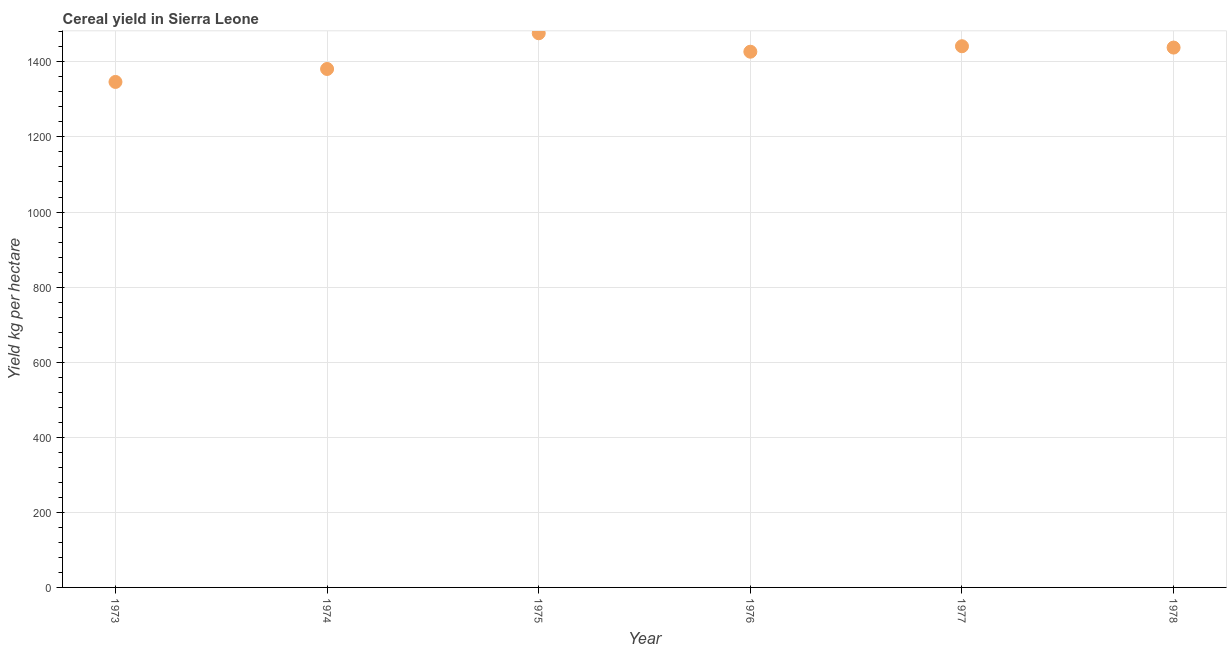What is the cereal yield in 1977?
Your answer should be very brief. 1441.64. Across all years, what is the maximum cereal yield?
Your answer should be very brief. 1476.21. Across all years, what is the minimum cereal yield?
Provide a short and direct response. 1346.54. In which year was the cereal yield maximum?
Your answer should be compact. 1975. What is the sum of the cereal yield?
Offer a terse response. 8510.59. What is the difference between the cereal yield in 1975 and 1976?
Ensure brevity in your answer.  49.15. What is the average cereal yield per year?
Give a very brief answer. 1418.43. What is the median cereal yield?
Give a very brief answer. 1432.57. In how many years, is the cereal yield greater than 80 kg per hectare?
Your answer should be very brief. 6. What is the ratio of the cereal yield in 1973 to that in 1976?
Your answer should be very brief. 0.94. Is the cereal yield in 1975 less than that in 1976?
Provide a succinct answer. No. What is the difference between the highest and the second highest cereal yield?
Provide a succinct answer. 34.56. What is the difference between the highest and the lowest cereal yield?
Give a very brief answer. 129.67. How many dotlines are there?
Give a very brief answer. 1. What is the difference between two consecutive major ticks on the Y-axis?
Make the answer very short. 200. Are the values on the major ticks of Y-axis written in scientific E-notation?
Your response must be concise. No. Does the graph contain grids?
Keep it short and to the point. Yes. What is the title of the graph?
Provide a short and direct response. Cereal yield in Sierra Leone. What is the label or title of the Y-axis?
Your answer should be very brief. Yield kg per hectare. What is the Yield kg per hectare in 1973?
Provide a succinct answer. 1346.54. What is the Yield kg per hectare in 1974?
Keep it short and to the point. 1381.07. What is the Yield kg per hectare in 1975?
Provide a succinct answer. 1476.21. What is the Yield kg per hectare in 1976?
Offer a very short reply. 1427.06. What is the Yield kg per hectare in 1977?
Your response must be concise. 1441.64. What is the Yield kg per hectare in 1978?
Keep it short and to the point. 1438.08. What is the difference between the Yield kg per hectare in 1973 and 1974?
Keep it short and to the point. -34.53. What is the difference between the Yield kg per hectare in 1973 and 1975?
Offer a very short reply. -129.67. What is the difference between the Yield kg per hectare in 1973 and 1976?
Provide a succinct answer. -80.52. What is the difference between the Yield kg per hectare in 1973 and 1977?
Provide a short and direct response. -95.11. What is the difference between the Yield kg per hectare in 1973 and 1978?
Give a very brief answer. -91.54. What is the difference between the Yield kg per hectare in 1974 and 1975?
Make the answer very short. -95.14. What is the difference between the Yield kg per hectare in 1974 and 1976?
Offer a very short reply. -45.99. What is the difference between the Yield kg per hectare in 1974 and 1977?
Give a very brief answer. -60.58. What is the difference between the Yield kg per hectare in 1974 and 1978?
Offer a very short reply. -57.01. What is the difference between the Yield kg per hectare in 1975 and 1976?
Make the answer very short. 49.15. What is the difference between the Yield kg per hectare in 1975 and 1977?
Offer a terse response. 34.56. What is the difference between the Yield kg per hectare in 1975 and 1978?
Provide a short and direct response. 38.13. What is the difference between the Yield kg per hectare in 1976 and 1977?
Offer a terse response. -14.59. What is the difference between the Yield kg per hectare in 1976 and 1978?
Give a very brief answer. -11.02. What is the difference between the Yield kg per hectare in 1977 and 1978?
Provide a short and direct response. 3.57. What is the ratio of the Yield kg per hectare in 1973 to that in 1974?
Provide a short and direct response. 0.97. What is the ratio of the Yield kg per hectare in 1973 to that in 1975?
Provide a succinct answer. 0.91. What is the ratio of the Yield kg per hectare in 1973 to that in 1976?
Offer a very short reply. 0.94. What is the ratio of the Yield kg per hectare in 1973 to that in 1977?
Your answer should be compact. 0.93. What is the ratio of the Yield kg per hectare in 1973 to that in 1978?
Your answer should be compact. 0.94. What is the ratio of the Yield kg per hectare in 1974 to that in 1975?
Keep it short and to the point. 0.94. What is the ratio of the Yield kg per hectare in 1974 to that in 1977?
Offer a very short reply. 0.96. What is the ratio of the Yield kg per hectare in 1974 to that in 1978?
Give a very brief answer. 0.96. What is the ratio of the Yield kg per hectare in 1975 to that in 1976?
Your response must be concise. 1.03. What is the ratio of the Yield kg per hectare in 1975 to that in 1977?
Your response must be concise. 1.02. What is the ratio of the Yield kg per hectare in 1975 to that in 1978?
Your answer should be compact. 1.03. What is the ratio of the Yield kg per hectare in 1976 to that in 1977?
Your answer should be very brief. 0.99. 